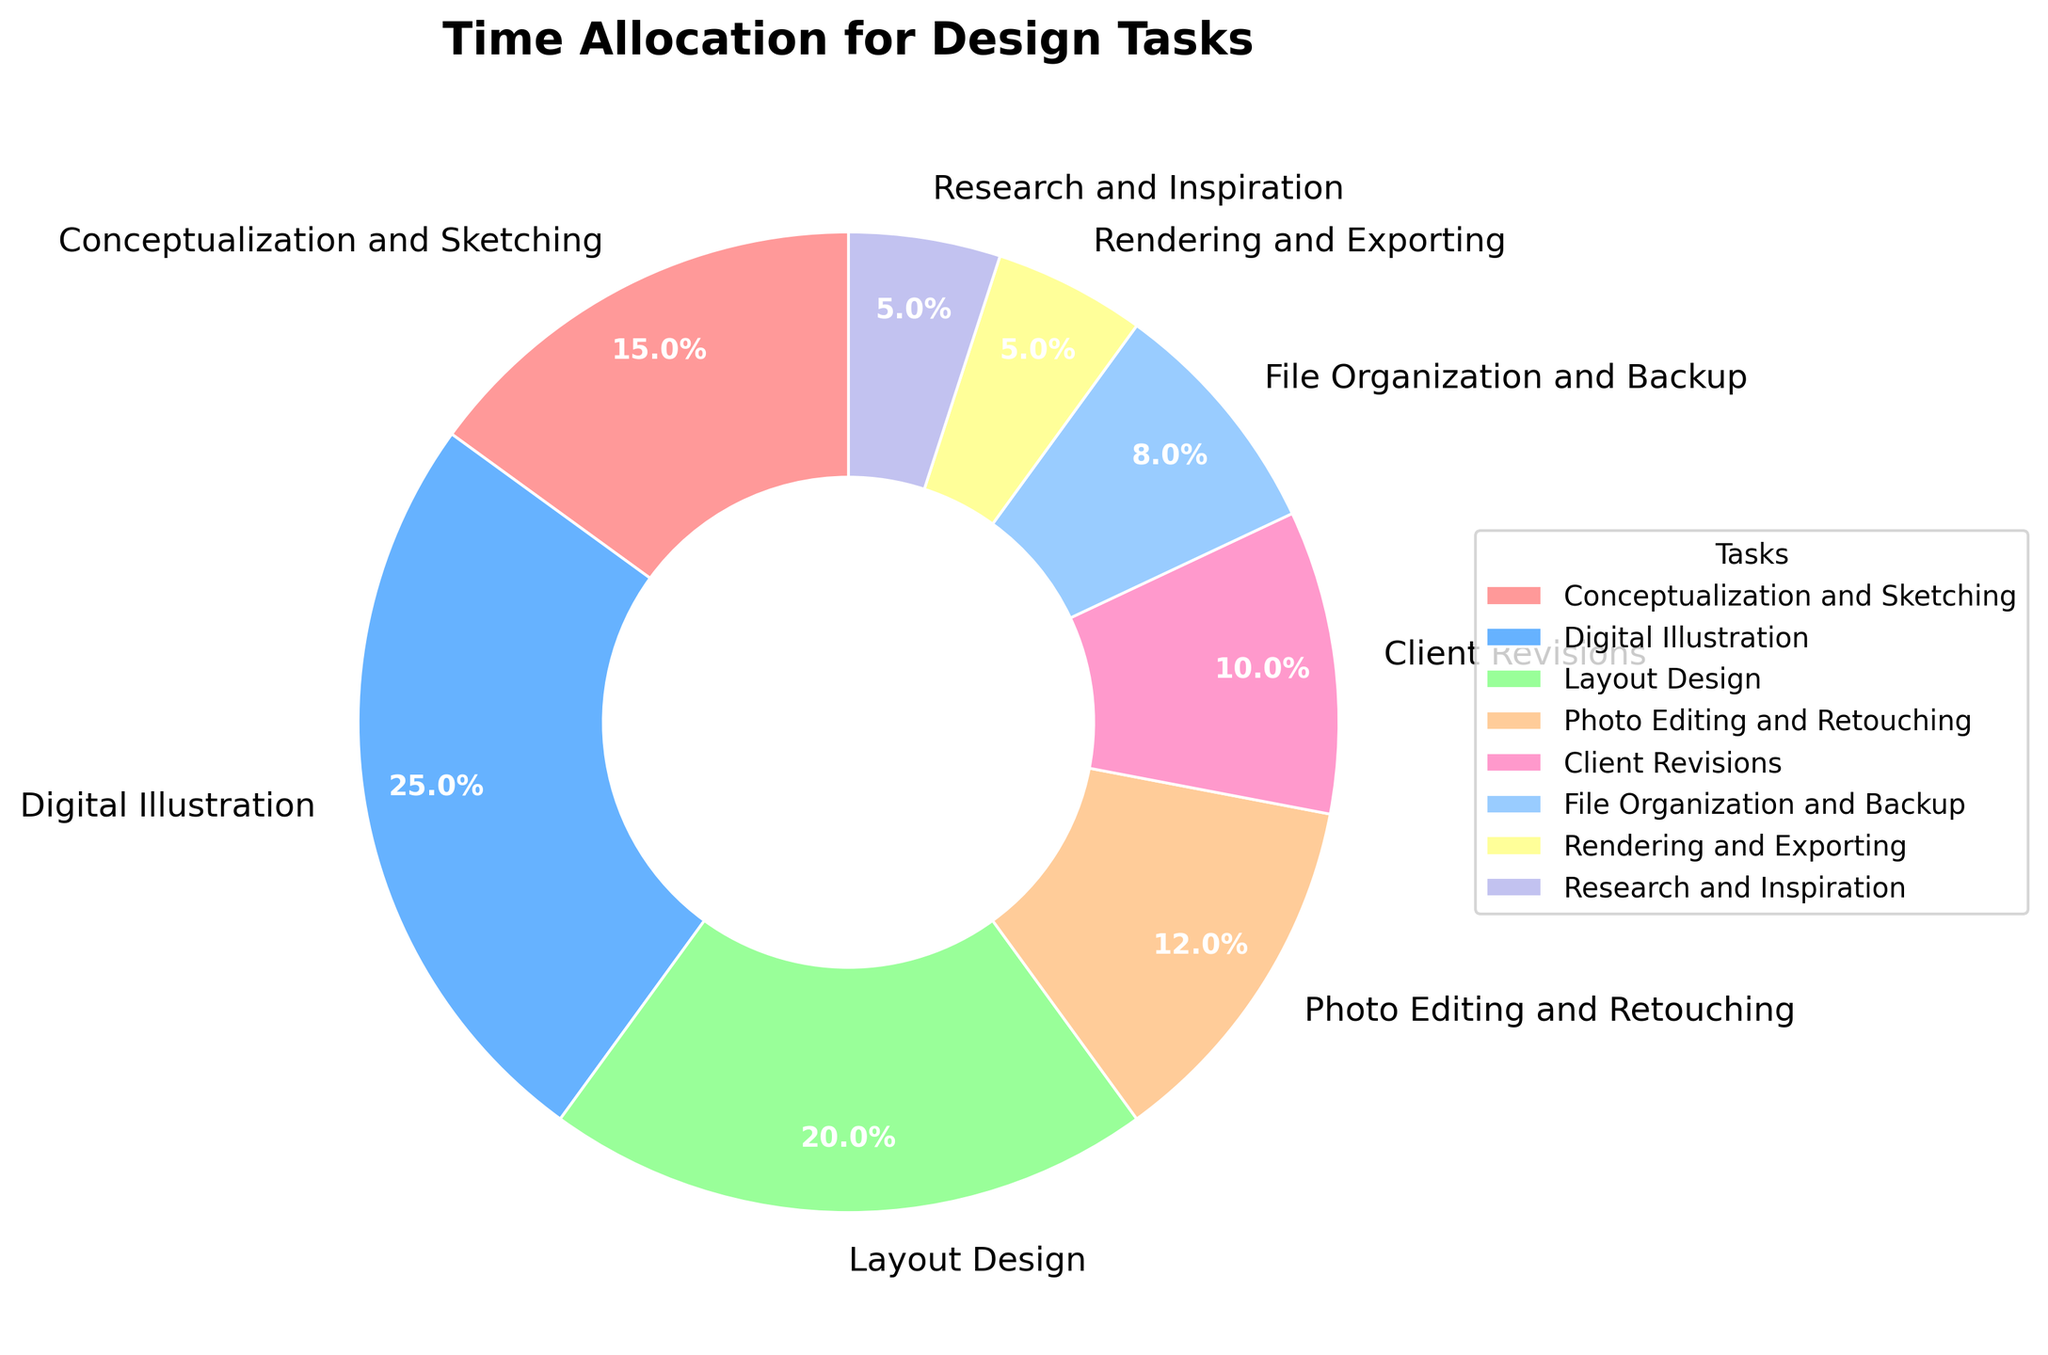What's the largest percentage task in the pie chart? The largest percentage task is the one with the highest percentage value. From the data, Digital Illustration has the highest percentage of 25%.
Answer: Digital Illustration Which two tasks have the smallest allocation of time, and what is their combined percentage? The smallest allocation of time includes the tasks with the smallest percentage values. From the data, Rendering and Exporting (5%) and Research and Inspiration (5%) have the smallest percentages. Their combined percentage is 5% + 5% = 10%.
Answer: Rendering and Exporting and Research and Inspiration, 10% What is the difference in time allocation between Layout Design and Client Revisions? To find the difference, subtract the smaller percentage from the larger one. Layout Design is 20%, and Client Revisions are 10%. The difference is 20% - 10% = 10%.
Answer: 10% How much more time is spent on Digital Illustration than on File Organization and Backup? To find out how much more time is spent, subtract the percentage of File Organization and Backup from Digital Illustration. Digital Illustration is 25%, and File Organization and Backup is 8%. The difference is 25% - 8% = 17%.
Answer: 17% Which task is represented by the red wedge, and what is its percentage? The red wedge corresponds to the first color in a typical pie chart's color sequence. According to the data, the first task is Conceptualization and Sketching with a percentage of 15%.
Answer: Conceptualization and Sketching, 15% Does Client Revisions take up more or less time than Photo Editing and Retouching? Compare the percentages of Client Revisions (10%) and Photo Editing and Retouching (12%). Client Revisions take up less time than Photo Editing and Retouching.
Answer: Less Which tasks have a time allocation greater than 10%? Identify tasks with percentages greater than 10%. These tasks are Conceptualization and Sketching (15%), Digital Illustration (25%), Layout Design (20%), and Photo Editing and Retouching (12%).
Answer: Conceptualization and Sketching, Digital Illustration, Layout Design, Photo Editing and Retouching What is the total percentage of time spent on tasks related to file handling (File Organization and Backup, Rendering and Exporting)? Add the percentages of File Organization and Backup (8%) and Rendering and Exporting (5%). The total is 8% + 5% = 13%.
Answer: 13% 